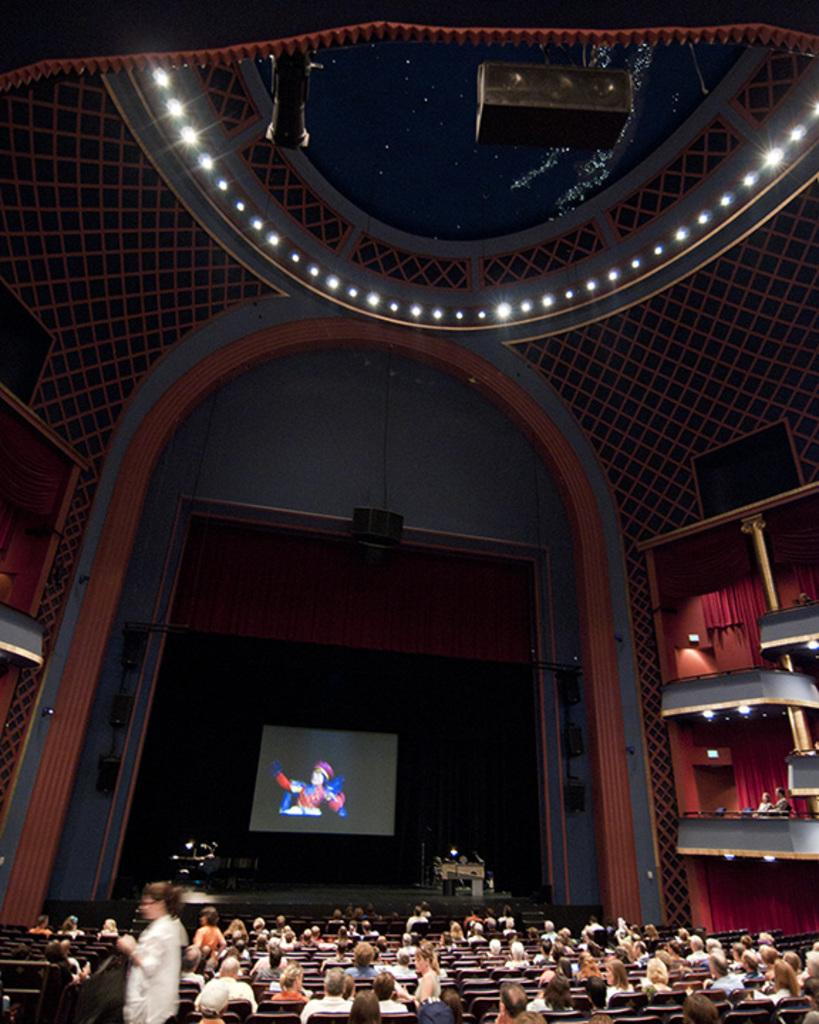What can be seen in the sky in the image? The sky is visible in the image, but no specific details about the sky can be determined from the provided facts. What type of lighting is present in the image? There are electric lights in the image. What device is used to project images in the image? A projector is present in the image. What is being projected onto in the image? There is a display screen in the image where the projection is being shown. What objects are used for making music in the image? Musical instruments are visible in the image. What is the raised platform called in the image? There is a dais in the image. Where are the persons sitting in the image? There are persons sitting on benches in the image. What type of structures are present in the image? Walls are present in the image. What type of window treatment is visible in the image? Curtains are visible in the image. Where is the body of the person who fainted during the event in the image? There is no mention of a person fainting in the image, so it is not possible to determine the location of their body. What type of tray is being used to serve food in the image? There is no mention of food or trays in the image, so it is not possible to determine if any trays are present. 